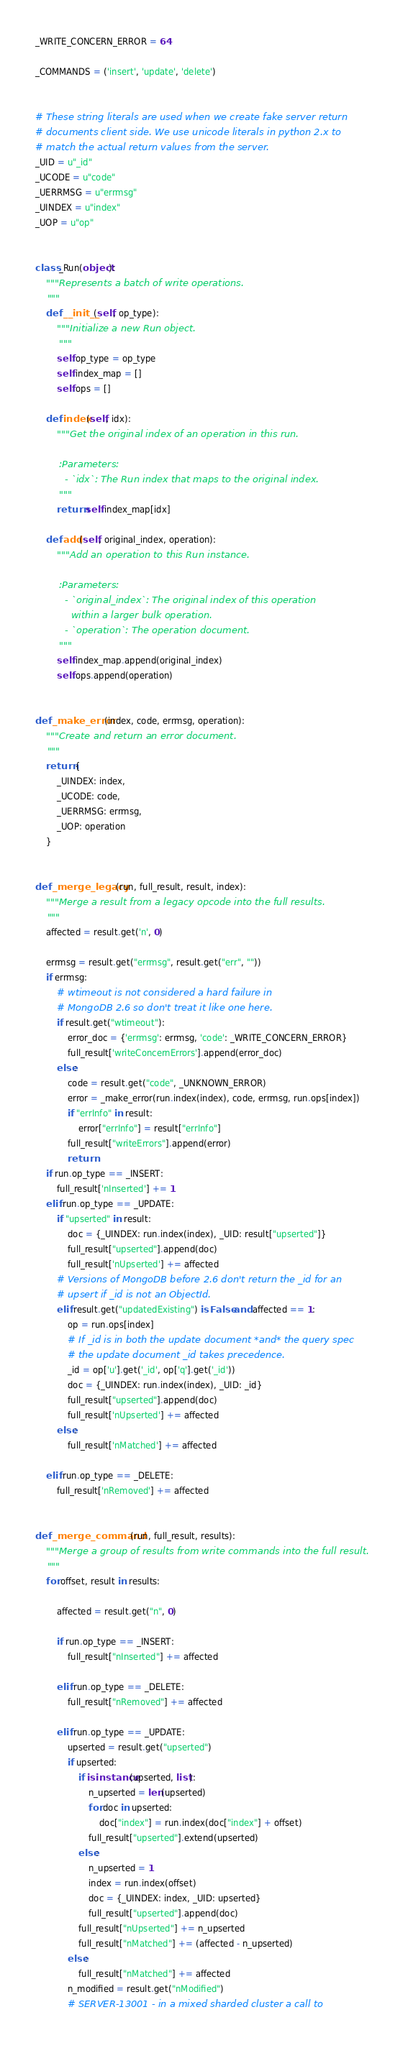Convert code to text. <code><loc_0><loc_0><loc_500><loc_500><_Python_>_WRITE_CONCERN_ERROR = 64

_COMMANDS = ('insert', 'update', 'delete')


# These string literals are used when we create fake server return
# documents client side. We use unicode literals in python 2.x to
# match the actual return values from the server.
_UID = u"_id"
_UCODE = u"code"
_UERRMSG = u"errmsg"
_UINDEX = u"index"
_UOP = u"op"


class _Run(object):
    """Represents a batch of write operations.
    """
    def __init__(self, op_type):
        """Initialize a new Run object.
        """
        self.op_type = op_type
        self.index_map = []
        self.ops = []

    def index(self, idx):
        """Get the original index of an operation in this run.

        :Parameters:
          - `idx`: The Run index that maps to the original index.
        """
        return self.index_map[idx]

    def add(self, original_index, operation):
        """Add an operation to this Run instance.

        :Parameters:
          - `original_index`: The original index of this operation
            within a larger bulk operation.
          - `operation`: The operation document.
        """
        self.index_map.append(original_index)
        self.ops.append(operation)


def _make_error(index, code, errmsg, operation):
    """Create and return an error document.
    """
    return {
        _UINDEX: index,
        _UCODE: code,
        _UERRMSG: errmsg,
        _UOP: operation
    }


def _merge_legacy(run, full_result, result, index):
    """Merge a result from a legacy opcode into the full results.
    """
    affected = result.get('n', 0)

    errmsg = result.get("errmsg", result.get("err", ""))
    if errmsg:
        # wtimeout is not considered a hard failure in
        # MongoDB 2.6 so don't treat it like one here.
        if result.get("wtimeout"):
            error_doc = {'errmsg': errmsg, 'code': _WRITE_CONCERN_ERROR}
            full_result['writeConcernErrors'].append(error_doc)
        else:
            code = result.get("code", _UNKNOWN_ERROR)
            error = _make_error(run.index(index), code, errmsg, run.ops[index])
            if "errInfo" in result:
                error["errInfo"] = result["errInfo"]
            full_result["writeErrors"].append(error)
            return
    if run.op_type == _INSERT:
        full_result['nInserted'] += 1
    elif run.op_type == _UPDATE:
        if "upserted" in result:
            doc = {_UINDEX: run.index(index), _UID: result["upserted"]}
            full_result["upserted"].append(doc)
            full_result['nUpserted'] += affected
        # Versions of MongoDB before 2.6 don't return the _id for an
        # upsert if _id is not an ObjectId.
        elif result.get("updatedExisting") is False and affected == 1:
            op = run.ops[index]
            # If _id is in both the update document *and* the query spec
            # the update document _id takes precedence.
            _id = op['u'].get('_id', op['q'].get('_id'))
            doc = {_UINDEX: run.index(index), _UID: _id}
            full_result["upserted"].append(doc)
            full_result['nUpserted'] += affected
        else:
            full_result['nMatched'] += affected

    elif run.op_type == _DELETE:
        full_result['nRemoved'] += affected


def _merge_command(run, full_result, results):
    """Merge a group of results from write commands into the full result.
    """
    for offset, result in results:

        affected = result.get("n", 0)

        if run.op_type == _INSERT:
            full_result["nInserted"] += affected

        elif run.op_type == _DELETE:
            full_result["nRemoved"] += affected

        elif run.op_type == _UPDATE:
            upserted = result.get("upserted")
            if upserted:
                if isinstance(upserted, list):
                    n_upserted = len(upserted)
                    for doc in upserted:
                        doc["index"] = run.index(doc["index"] + offset)
                    full_result["upserted"].extend(upserted)
                else:
                    n_upserted = 1
                    index = run.index(offset)
                    doc = {_UINDEX: index, _UID: upserted}
                    full_result["upserted"].append(doc)
                full_result["nUpserted"] += n_upserted
                full_result["nMatched"] += (affected - n_upserted)
            else:
                full_result["nMatched"] += affected
            n_modified = result.get("nModified")
            # SERVER-13001 - in a mixed sharded cluster a call to</code> 